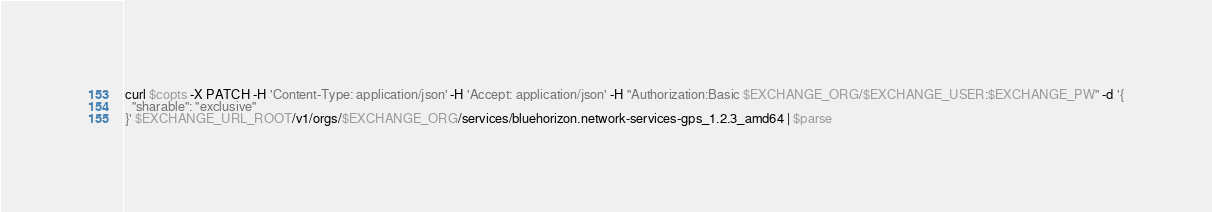<code> <loc_0><loc_0><loc_500><loc_500><_Bash_>
curl $copts -X PATCH -H 'Content-Type: application/json' -H 'Accept: application/json' -H "Authorization:Basic $EXCHANGE_ORG/$EXCHANGE_USER:$EXCHANGE_PW" -d '{
  "sharable": "exclusive"
}' $EXCHANGE_URL_ROOT/v1/orgs/$EXCHANGE_ORG/services/bluehorizon.network-services-gps_1.2.3_amd64 | $parse
</code> 